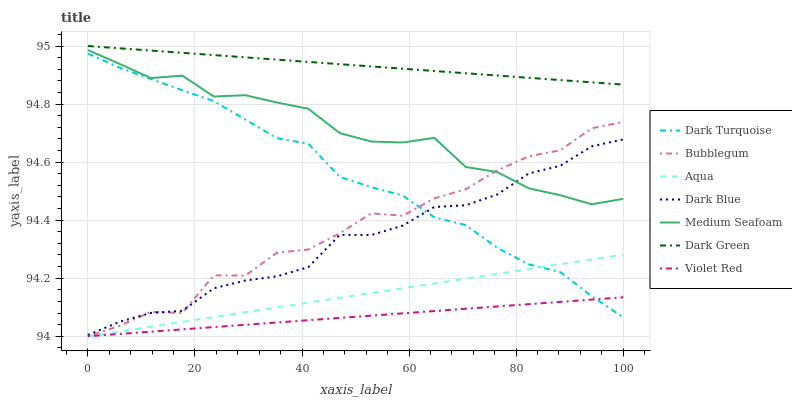Does Violet Red have the minimum area under the curve?
Answer yes or no. Yes. Does Dark Green have the maximum area under the curve?
Answer yes or no. Yes. Does Dark Turquoise have the minimum area under the curve?
Answer yes or no. No. Does Dark Turquoise have the maximum area under the curve?
Answer yes or no. No. Is Violet Red the smoothest?
Answer yes or no. Yes. Is Bubblegum the roughest?
Answer yes or no. Yes. Is Dark Turquoise the smoothest?
Answer yes or no. No. Is Dark Turquoise the roughest?
Answer yes or no. No. Does Violet Red have the lowest value?
Answer yes or no. Yes. Does Dark Turquoise have the lowest value?
Answer yes or no. No. Does Dark Green have the highest value?
Answer yes or no. Yes. Does Dark Turquoise have the highest value?
Answer yes or no. No. Is Medium Seafoam less than Dark Green?
Answer yes or no. Yes. Is Dark Green greater than Violet Red?
Answer yes or no. Yes. Does Aqua intersect Violet Red?
Answer yes or no. Yes. Is Aqua less than Violet Red?
Answer yes or no. No. Is Aqua greater than Violet Red?
Answer yes or no. No. Does Medium Seafoam intersect Dark Green?
Answer yes or no. No. 